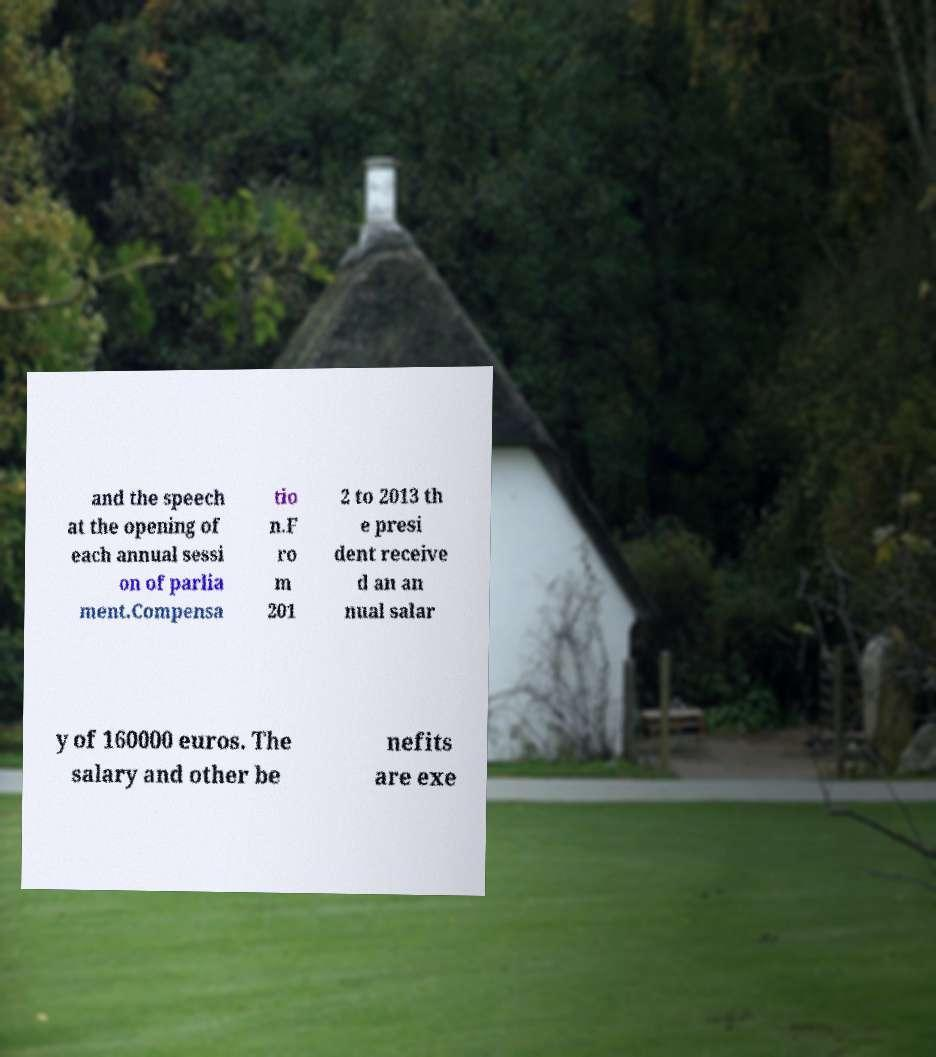Please read and relay the text visible in this image. What does it say? and the speech at the opening of each annual sessi on of parlia ment.Compensa tio n.F ro m 201 2 to 2013 th e presi dent receive d an an nual salar y of 160000 euros. The salary and other be nefits are exe 